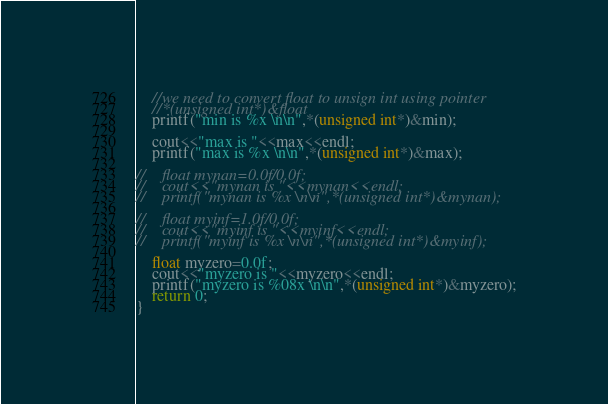Convert code to text. <code><loc_0><loc_0><loc_500><loc_500><_C++_>    //we need to convert float to unsign int using pointer
    //*(unsigned int*)&float
    printf("min is %x \n\n",*(unsigned int*)&min);
    
    cout<<"max is "<<max<<endl;
    printf("max is %x \n\n",*(unsigned int*)&max);
    
//    float mynan=0.0f/0.0f;
//    cout<<"mynan is "<<mynan<<endl;
//    printf("mynan is %x \n\n",*(unsigned int*)&mynan);
    
//    float myinf=1.0f/0.0f;
//    cout<<"myinf is "<<myinf<<endl;
//    printf("myinf is %x \n\n",*(unsigned int*)&myinf);
    
    float myzero=0.0f;
    cout<<"myzero is "<<myzero<<endl;
    printf("myzero is %08x \n\n",*(unsigned int*)&myzero);
    return 0;
}
</code> 